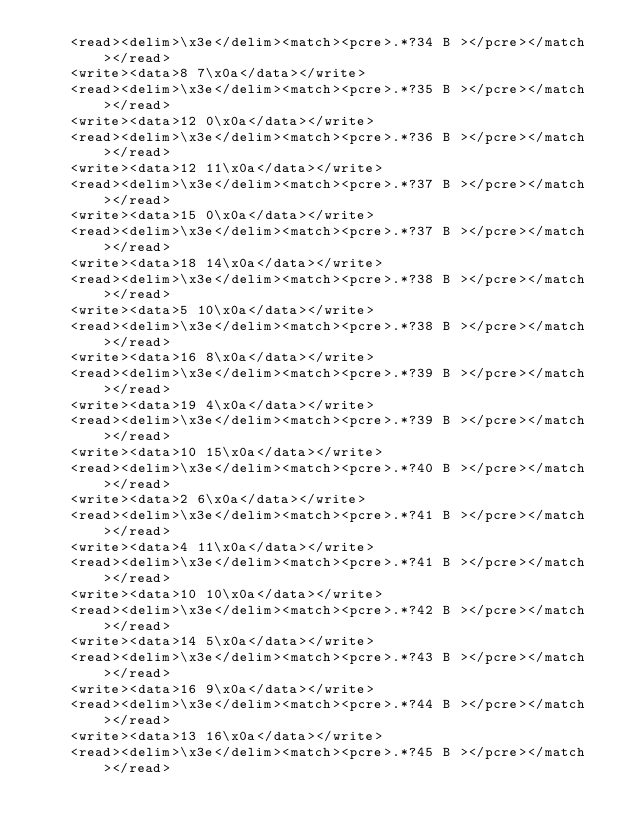Convert code to text. <code><loc_0><loc_0><loc_500><loc_500><_XML_>    <read><delim>\x3e</delim><match><pcre>.*?34 B ></pcre></match></read>
    <write><data>8 7\x0a</data></write>
    <read><delim>\x3e</delim><match><pcre>.*?35 B ></pcre></match></read>
    <write><data>12 0\x0a</data></write>
    <read><delim>\x3e</delim><match><pcre>.*?36 B ></pcre></match></read>
    <write><data>12 11\x0a</data></write>
    <read><delim>\x3e</delim><match><pcre>.*?37 B ></pcre></match></read>
    <write><data>15 0\x0a</data></write>
    <read><delim>\x3e</delim><match><pcre>.*?37 B ></pcre></match></read>
    <write><data>18 14\x0a</data></write>
    <read><delim>\x3e</delim><match><pcre>.*?38 B ></pcre></match></read>
    <write><data>5 10\x0a</data></write>
    <read><delim>\x3e</delim><match><pcre>.*?38 B ></pcre></match></read>
    <write><data>16 8\x0a</data></write>
    <read><delim>\x3e</delim><match><pcre>.*?39 B ></pcre></match></read>
    <write><data>19 4\x0a</data></write>
    <read><delim>\x3e</delim><match><pcre>.*?39 B ></pcre></match></read>
    <write><data>10 15\x0a</data></write>
    <read><delim>\x3e</delim><match><pcre>.*?40 B ></pcre></match></read>
    <write><data>2 6\x0a</data></write>
    <read><delim>\x3e</delim><match><pcre>.*?41 B ></pcre></match></read>
    <write><data>4 11\x0a</data></write>
    <read><delim>\x3e</delim><match><pcre>.*?41 B ></pcre></match></read>
    <write><data>10 10\x0a</data></write>
    <read><delim>\x3e</delim><match><pcre>.*?42 B ></pcre></match></read>
    <write><data>14 5\x0a</data></write>
    <read><delim>\x3e</delim><match><pcre>.*?43 B ></pcre></match></read>
    <write><data>16 9\x0a</data></write>
    <read><delim>\x3e</delim><match><pcre>.*?44 B ></pcre></match></read>
    <write><data>13 16\x0a</data></write>
    <read><delim>\x3e</delim><match><pcre>.*?45 B ></pcre></match></read></code> 